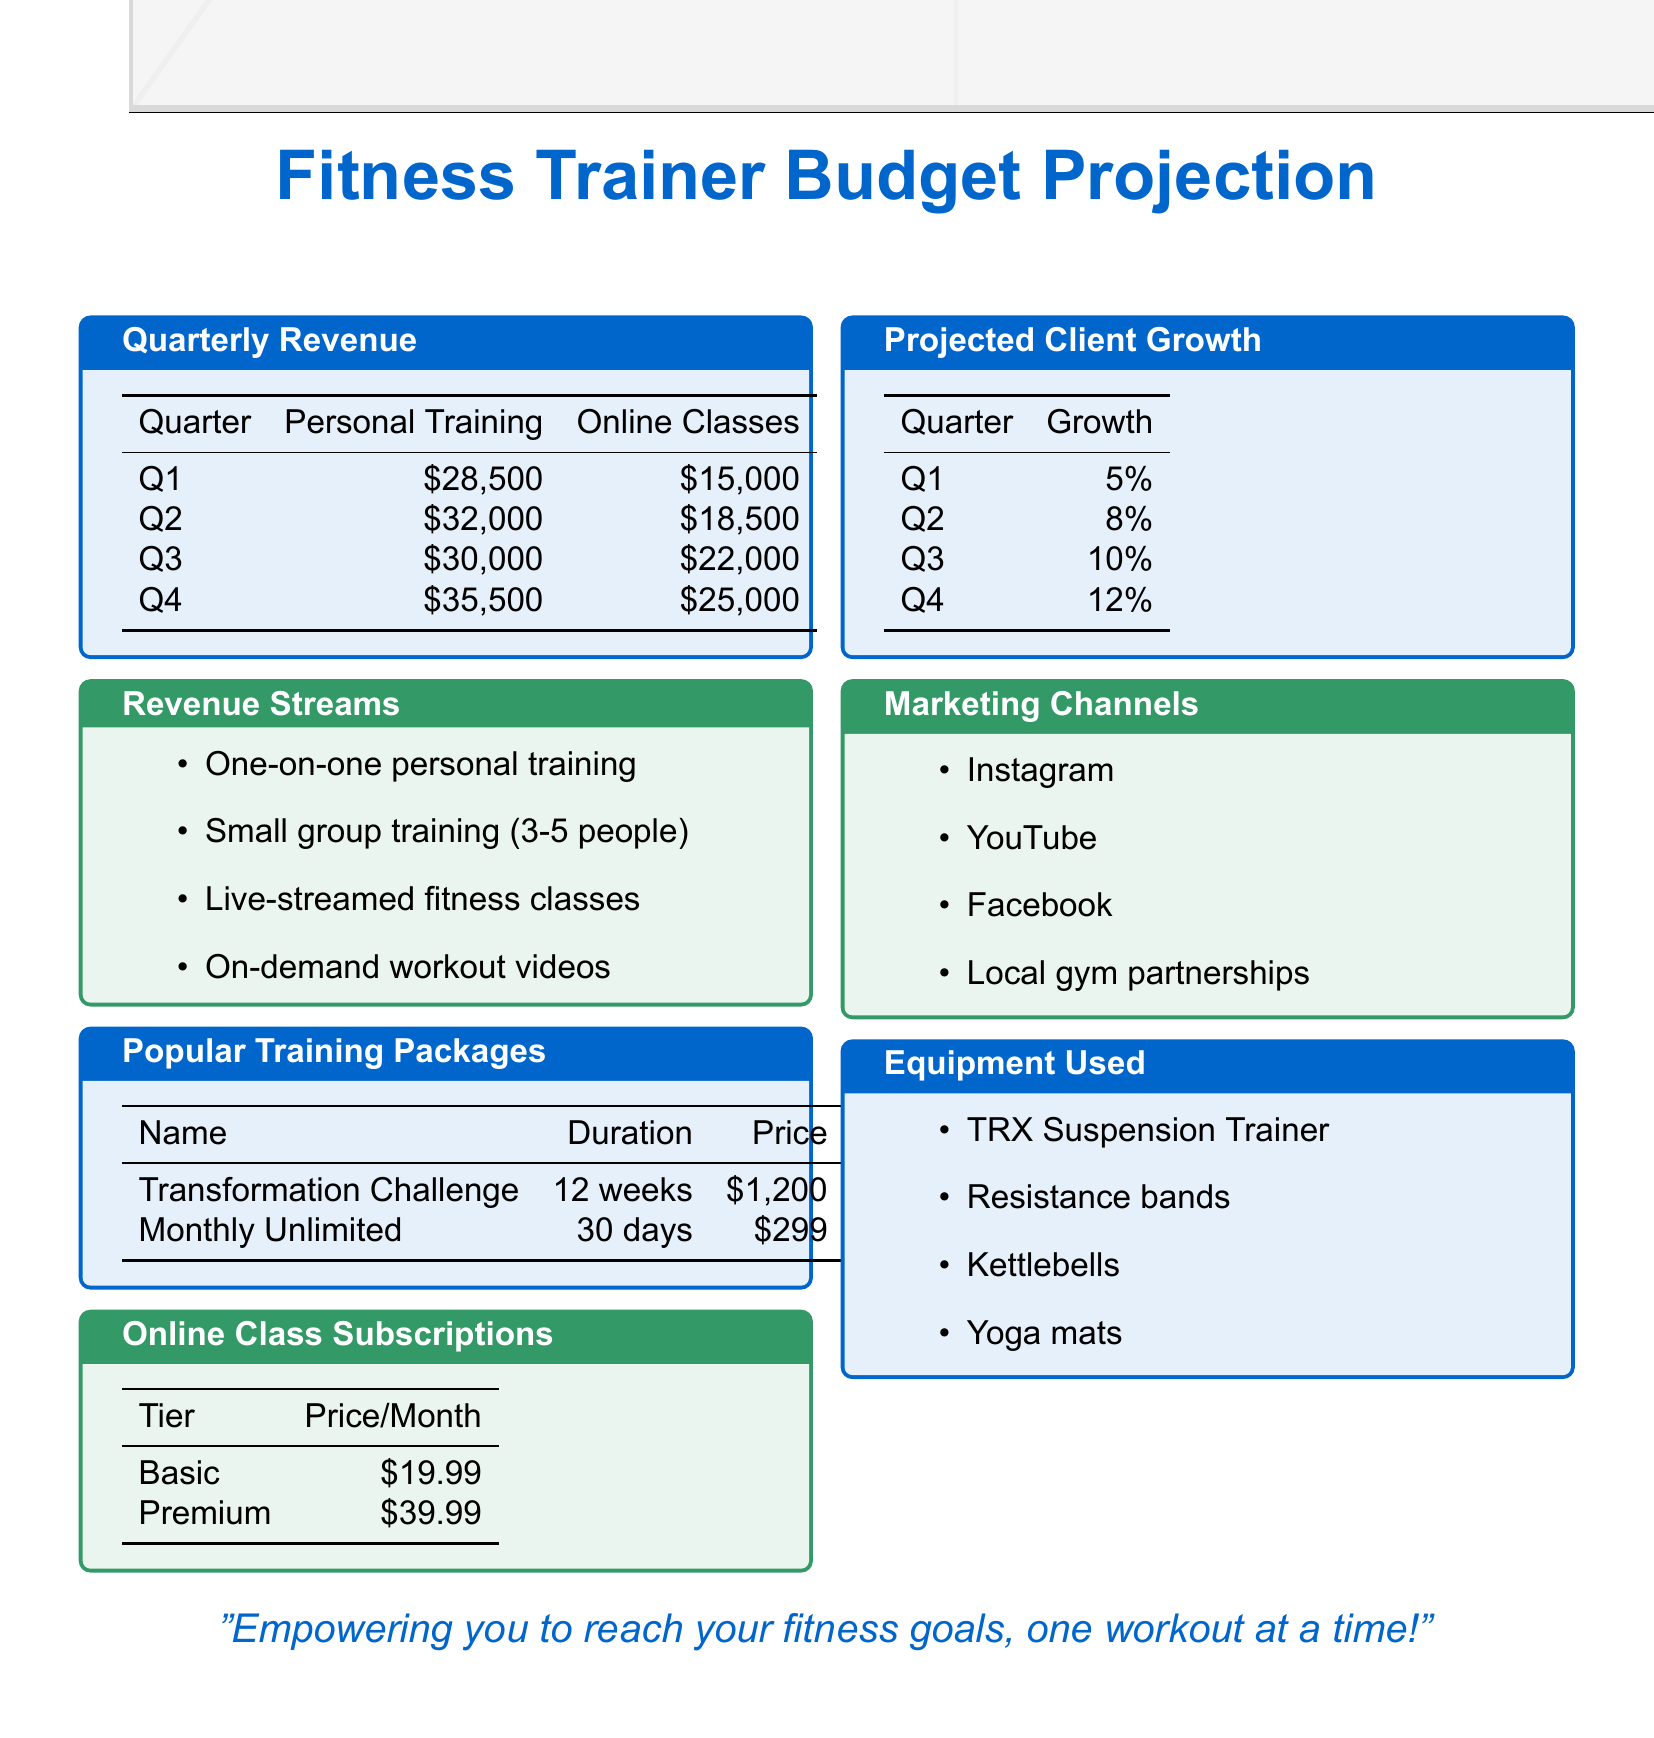What is the projected revenue from personal training in Q3? The projected revenue from personal training in Q3 is specified in the document as $30,000.
Answer: $30,000 What is the price of the Premium online class subscription? The price of the Premium online class subscription is detailed in the document as $39.99 per month.
Answer: $39.99 Which quarterly revenue shows the highest amount for online classes? To determine which quarter has the highest revenue for online classes, the values for each quarter need to be compared. Q4 shows the highest with $25,000.
Answer: $25,000 What growth percentage is projected for Q2? The growth percentage for Q2 is mentioned in the document as 8%.
Answer: 8% What is the price of the Transformation Challenge package? The document states the price of the Transformation Challenge package is $1,200.
Answer: $1,200 How much additional revenue will Online Classes bring in Q4 compared to Q1? The additional revenue is calculated by subtracting Q1 from Q4 for Online Classes, $25,000 - $15,000 = $10,000.
Answer: $10,000 Which marketing channel is included in the document? The document lists Instagram as one of the marketing channels.
Answer: Instagram What type of training does the Monthly Unlimited package cover? The Monthly Unlimited package covers unlimited sessions within a 30-day period based on the document.
Answer: Unlimited sessions 